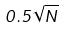Convert formula to latex. <formula><loc_0><loc_0><loc_500><loc_500>0 . 5 \sqrt { N }</formula> 